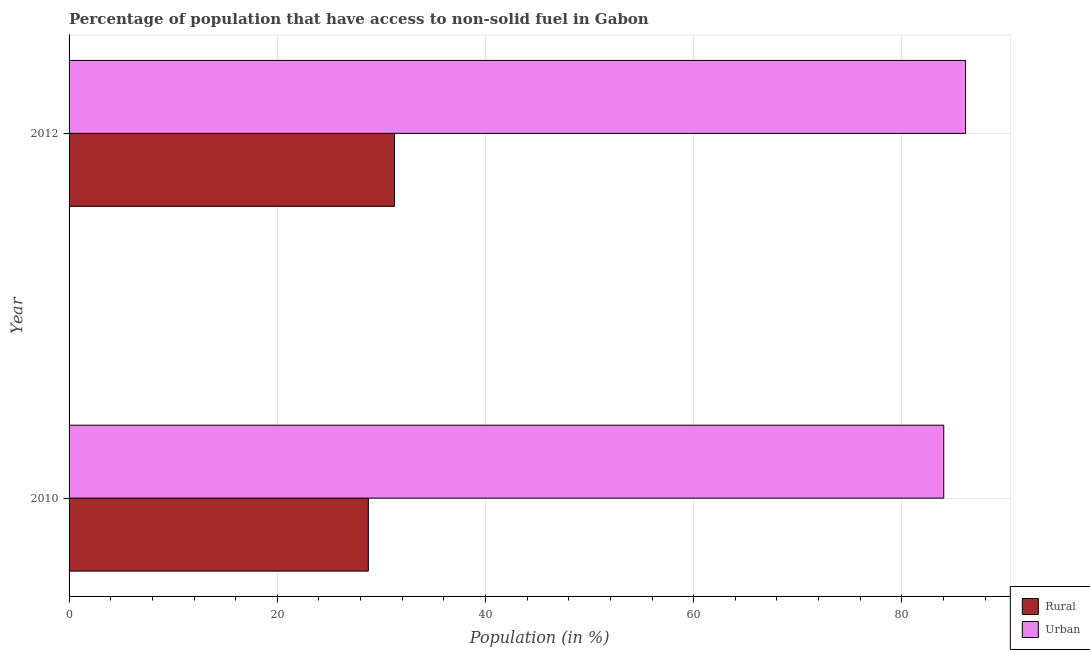How many groups of bars are there?
Your answer should be very brief. 2. Are the number of bars per tick equal to the number of legend labels?
Your answer should be compact. Yes. How many bars are there on the 1st tick from the top?
Ensure brevity in your answer.  2. How many bars are there on the 1st tick from the bottom?
Keep it short and to the point. 2. What is the label of the 2nd group of bars from the top?
Your response must be concise. 2010. In how many cases, is the number of bars for a given year not equal to the number of legend labels?
Give a very brief answer. 0. What is the urban population in 2010?
Offer a very short reply. 84.02. Across all years, what is the maximum rural population?
Keep it short and to the point. 31.26. Across all years, what is the minimum rural population?
Ensure brevity in your answer.  28.75. In which year was the rural population minimum?
Provide a short and direct response. 2010. What is the total urban population in the graph?
Ensure brevity in your answer.  170.13. What is the difference between the urban population in 2010 and that in 2012?
Keep it short and to the point. -2.09. What is the difference between the urban population in 2010 and the rural population in 2012?
Your answer should be compact. 52.76. What is the average rural population per year?
Provide a succinct answer. 30. In the year 2012, what is the difference between the rural population and urban population?
Offer a terse response. -54.85. In how many years, is the urban population greater than 44 %?
Your answer should be very brief. 2. Is the urban population in 2010 less than that in 2012?
Provide a succinct answer. Yes. Is the difference between the urban population in 2010 and 2012 greater than the difference between the rural population in 2010 and 2012?
Make the answer very short. Yes. In how many years, is the rural population greater than the average rural population taken over all years?
Your answer should be compact. 1. What does the 1st bar from the top in 2012 represents?
Provide a succinct answer. Urban. What does the 2nd bar from the bottom in 2010 represents?
Give a very brief answer. Urban. How many bars are there?
Make the answer very short. 4. How many years are there in the graph?
Provide a succinct answer. 2. Where does the legend appear in the graph?
Offer a very short reply. Bottom right. How many legend labels are there?
Ensure brevity in your answer.  2. How are the legend labels stacked?
Provide a succinct answer. Vertical. What is the title of the graph?
Give a very brief answer. Percentage of population that have access to non-solid fuel in Gabon. Does "Infant" appear as one of the legend labels in the graph?
Your answer should be compact. No. What is the label or title of the Y-axis?
Offer a very short reply. Year. What is the Population (in %) of Rural in 2010?
Provide a short and direct response. 28.75. What is the Population (in %) in Urban in 2010?
Keep it short and to the point. 84.02. What is the Population (in %) of Rural in 2012?
Your answer should be very brief. 31.26. What is the Population (in %) in Urban in 2012?
Keep it short and to the point. 86.11. Across all years, what is the maximum Population (in %) of Rural?
Offer a very short reply. 31.26. Across all years, what is the maximum Population (in %) of Urban?
Your answer should be compact. 86.11. Across all years, what is the minimum Population (in %) of Rural?
Provide a short and direct response. 28.75. Across all years, what is the minimum Population (in %) in Urban?
Make the answer very short. 84.02. What is the total Population (in %) of Rural in the graph?
Give a very brief answer. 60.01. What is the total Population (in %) in Urban in the graph?
Your answer should be very brief. 170.13. What is the difference between the Population (in %) in Rural in 2010 and that in 2012?
Your response must be concise. -2.51. What is the difference between the Population (in %) of Urban in 2010 and that in 2012?
Your answer should be compact. -2.09. What is the difference between the Population (in %) of Rural in 2010 and the Population (in %) of Urban in 2012?
Offer a very short reply. -57.36. What is the average Population (in %) in Rural per year?
Offer a very short reply. 30. What is the average Population (in %) of Urban per year?
Offer a terse response. 85.06. In the year 2010, what is the difference between the Population (in %) in Rural and Population (in %) in Urban?
Make the answer very short. -55.27. In the year 2012, what is the difference between the Population (in %) in Rural and Population (in %) in Urban?
Your answer should be compact. -54.85. What is the ratio of the Population (in %) of Rural in 2010 to that in 2012?
Provide a succinct answer. 0.92. What is the ratio of the Population (in %) in Urban in 2010 to that in 2012?
Provide a short and direct response. 0.98. What is the difference between the highest and the second highest Population (in %) in Rural?
Offer a very short reply. 2.51. What is the difference between the highest and the second highest Population (in %) in Urban?
Offer a very short reply. 2.09. What is the difference between the highest and the lowest Population (in %) of Rural?
Ensure brevity in your answer.  2.51. What is the difference between the highest and the lowest Population (in %) of Urban?
Your answer should be compact. 2.09. 